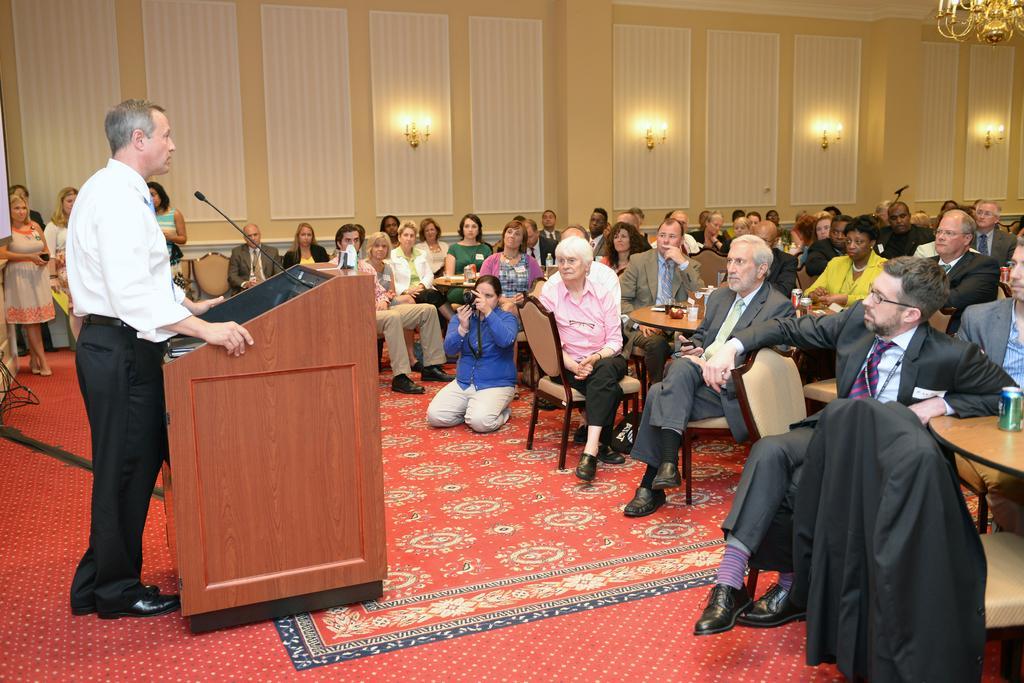Could you give a brief overview of what you see in this image? This picture shows a meeting room were group of people seated on the chairs and a person is standing in front of a podium and speaking with the help of a microphone and we see a woman taking photographs with a camera 